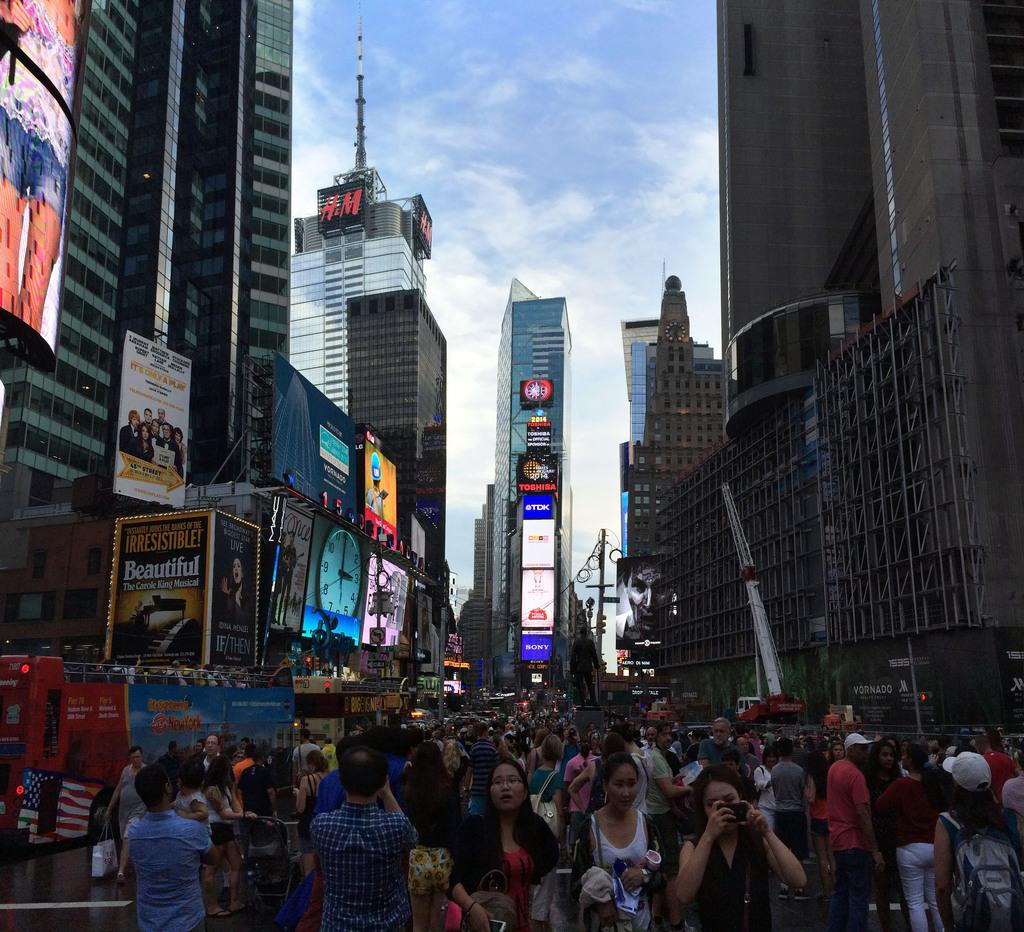Provide a one-sentence caption for the provided image. The city of New York crowded with tourists with many ads on the buildings like H and M and Beautiful movie. 